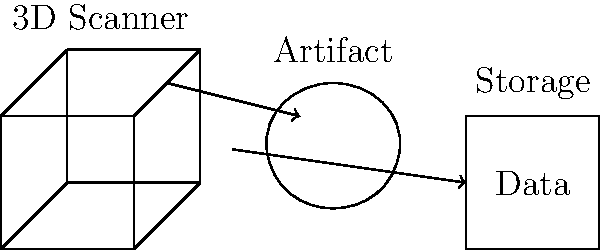In the digital archiving process of cultural artifacts, what is the primary advantage of using 3D scanning technology over traditional 2D photography? To understand the advantage of 3D scanning over 2D photography in digital archiving of cultural artifacts, let's consider the process step-by-step:

1. Data capture:
   - 2D photography captures only the visible surface from a single angle.
   - 3D scanning captures the entire surface geometry of the artifact.

2. Depth information:
   - 2D images lack depth information.
   - 3D scans provide accurate depth data, allowing for precise measurements.

3. Perspective:
   - 2D images are limited to the photographer's chosen angle.
   - 3D scans allow for viewing the artifact from any angle.

4. Texture mapping:
   - 2D images capture color and texture but only from one perspective.
   - 3D scans can map textures onto the entire surface, providing a complete representation.

5. Digital manipulation:
   - 2D images can be edited but not easily manipulated in 3D space.
   - 3D scans can be rotated, scaled, and analyzed in virtual environments.

6. Preservation:
   - 2D images document the visual appearance at a specific time.
   - 3D scans create a digital replica that can be used for monitoring changes over time or even 3D printing replicas.

7. Research and access:
   - 2D images limit detailed study to what's visible in the photograph.
   - 3D scans allow researchers to examine minute details from any angle without physical access to the artifact.

The primary advantage of 3D scanning is its ability to capture and preserve the complete three-dimensional form of an artifact, allowing for more comprehensive documentation, analysis, and virtual interaction.
Answer: Comprehensive 3D geometry capture 